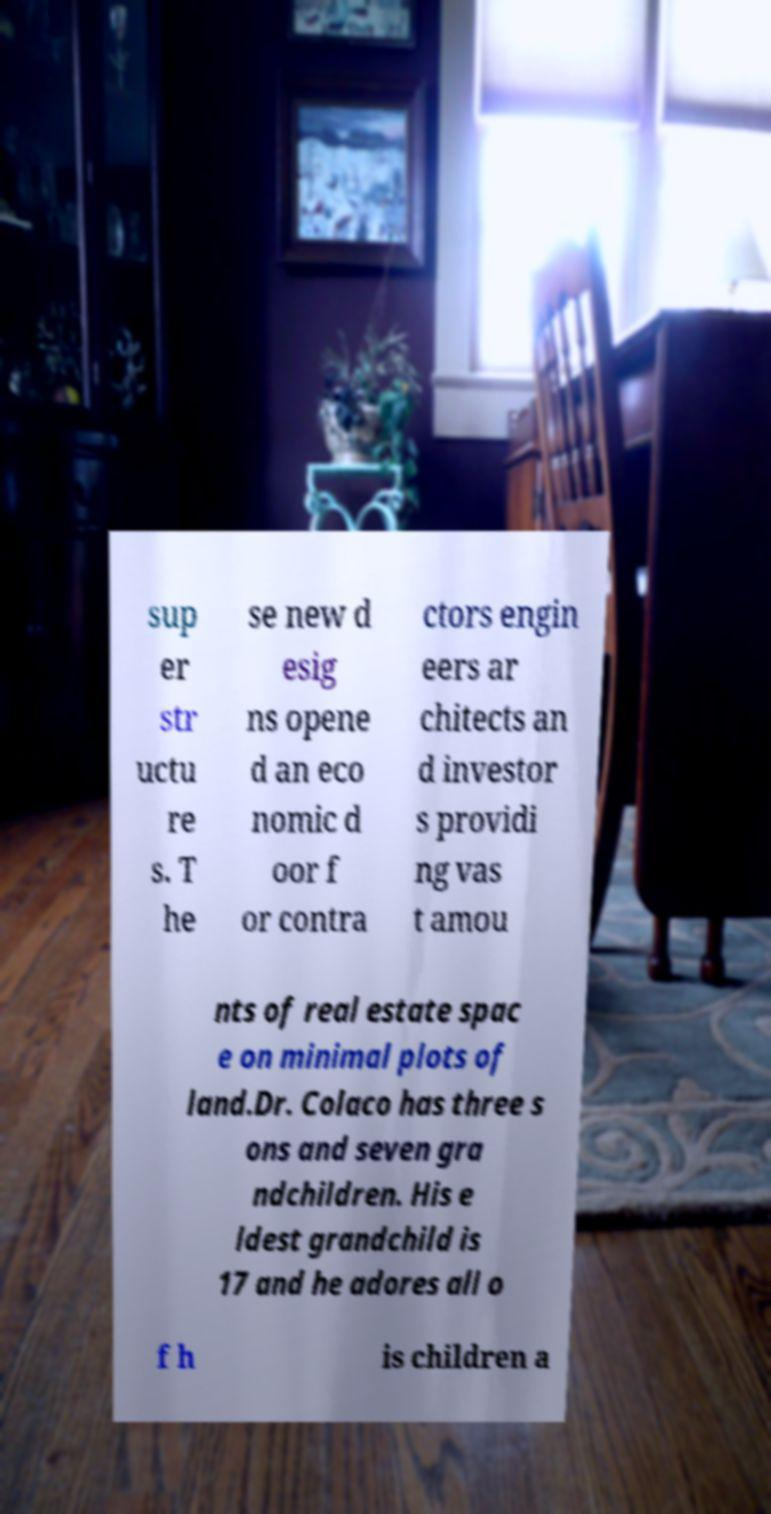Please read and relay the text visible in this image. What does it say? sup er str uctu re s. T he se new d esig ns opene d an eco nomic d oor f or contra ctors engin eers ar chitects an d investor s providi ng vas t amou nts of real estate spac e on minimal plots of land.Dr. Colaco has three s ons and seven gra ndchildren. His e ldest grandchild is 17 and he adores all o f h is children a 